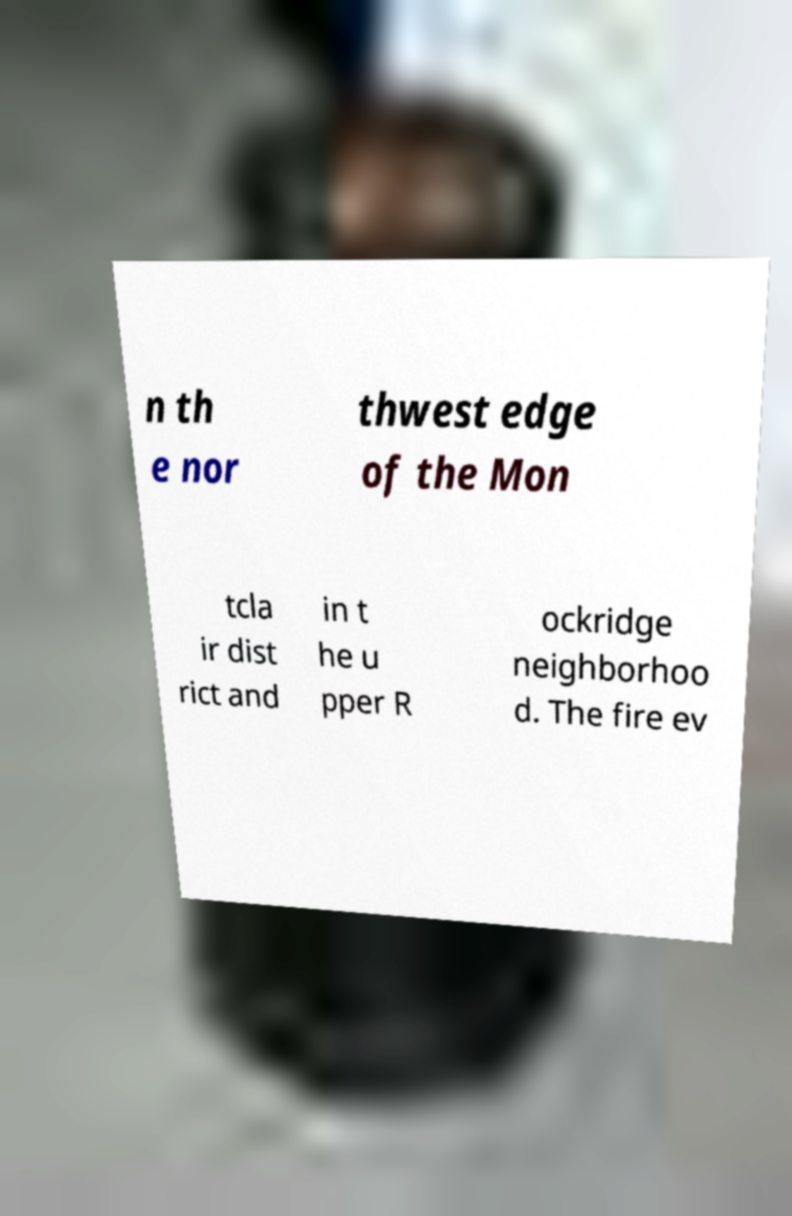Can you accurately transcribe the text from the provided image for me? n th e nor thwest edge of the Mon tcla ir dist rict and in t he u pper R ockridge neighborhoo d. The fire ev 